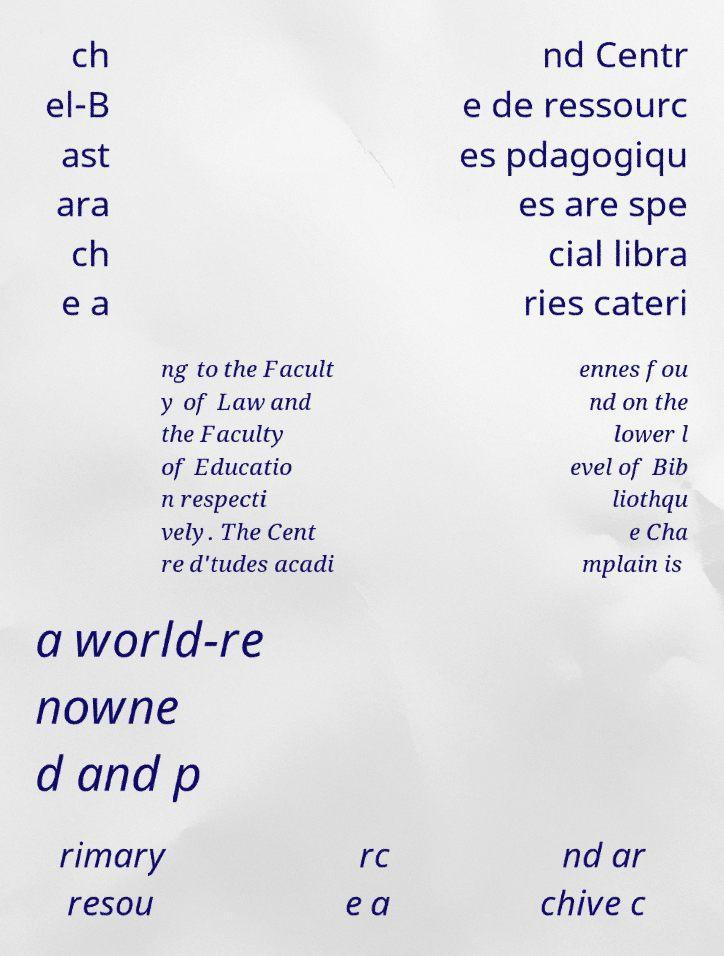Please identify and transcribe the text found in this image. ch el-B ast ara ch e a nd Centr e de ressourc es pdagogiqu es are spe cial libra ries cateri ng to the Facult y of Law and the Faculty of Educatio n respecti vely. The Cent re d'tudes acadi ennes fou nd on the lower l evel of Bib liothqu e Cha mplain is a world-re nowne d and p rimary resou rc e a nd ar chive c 